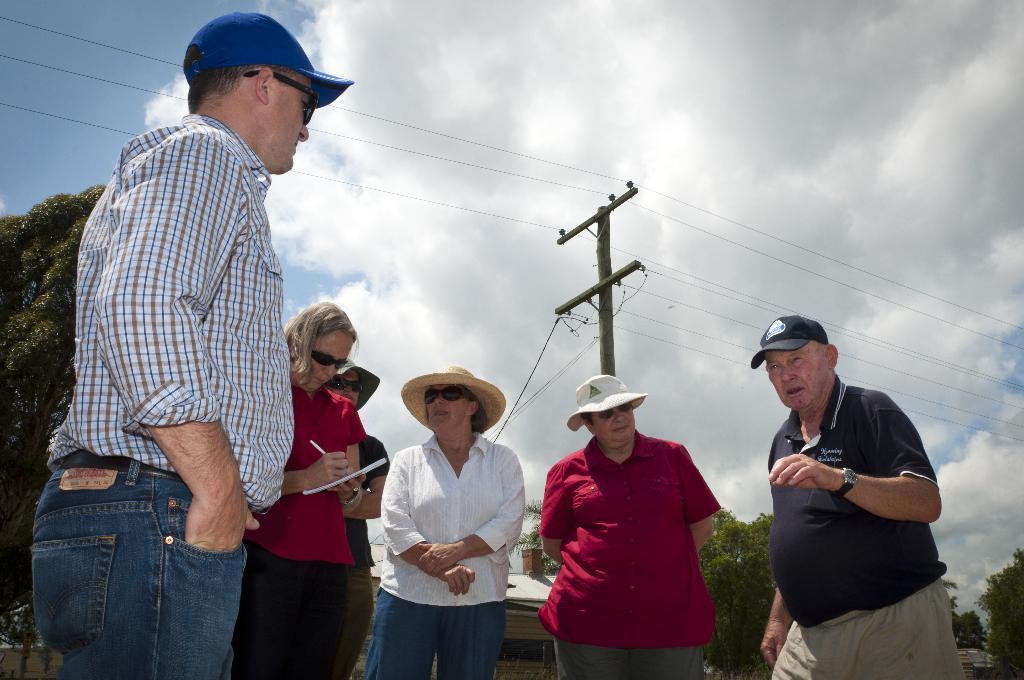Could you give a brief overview of what you see in this image? This is an outside view. Here I can see few people standing. The man who is on the right side it seems like he is speaking and remaining are looking at this man and all are having caps on their heads. In the background, I can see few trees and building and also there is a pole along with the wires. At the top of the image I can see the sky and clouds. 